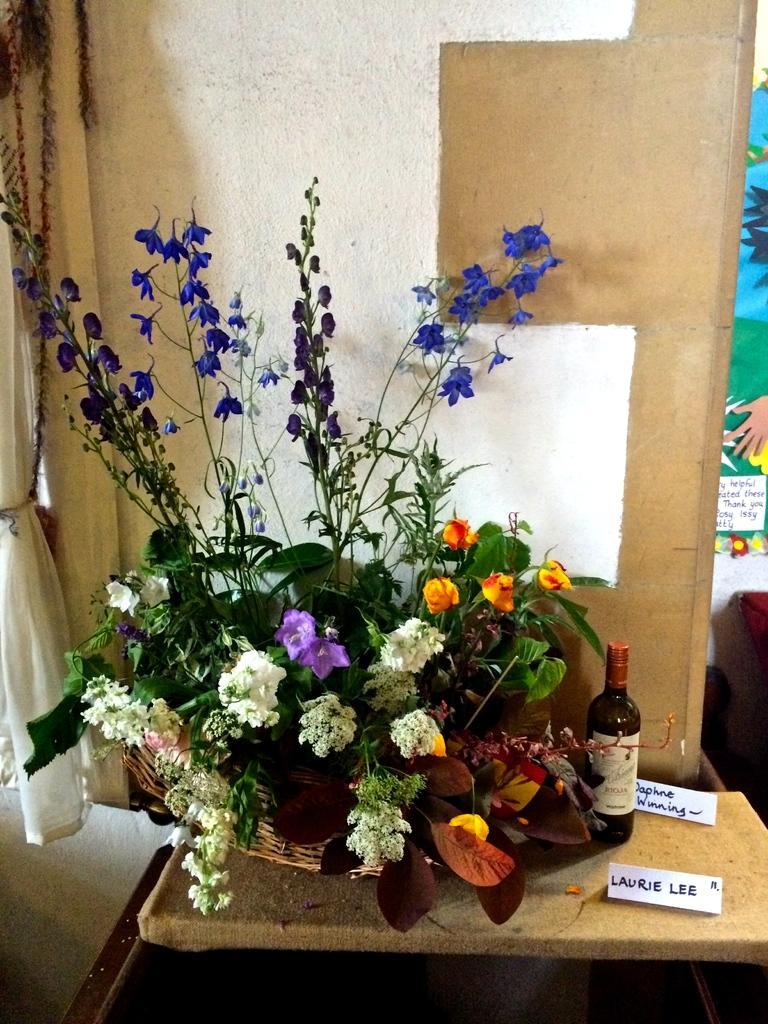Please provide a concise description of this image. This is the picture of a room. In this image there are flowers in the basket and there is a bottle and there are papers on the table. At the back there is a poster on the wall. On the left side of the image there is a curtain. 